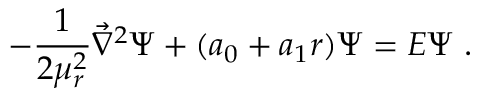<formula> <loc_0><loc_0><loc_500><loc_500>- { \frac { 1 } { 2 \mu _ { r } ^ { 2 } } } { \vec { \nabla } } ^ { 2 } \Psi + ( a _ { 0 } + a _ { 1 } r ) \Psi = E \Psi \ .</formula> 